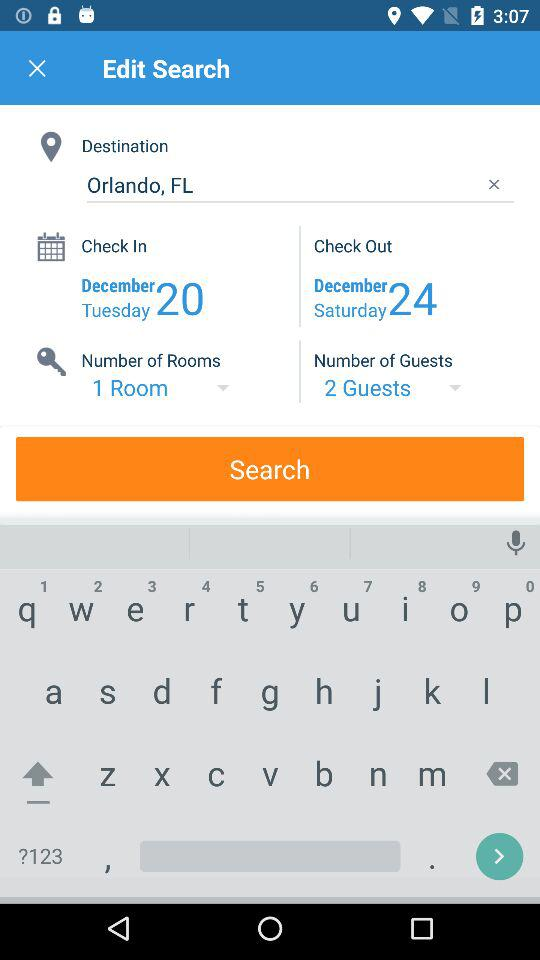What was the day on December 24th? The day on December 24th was Saturday. 